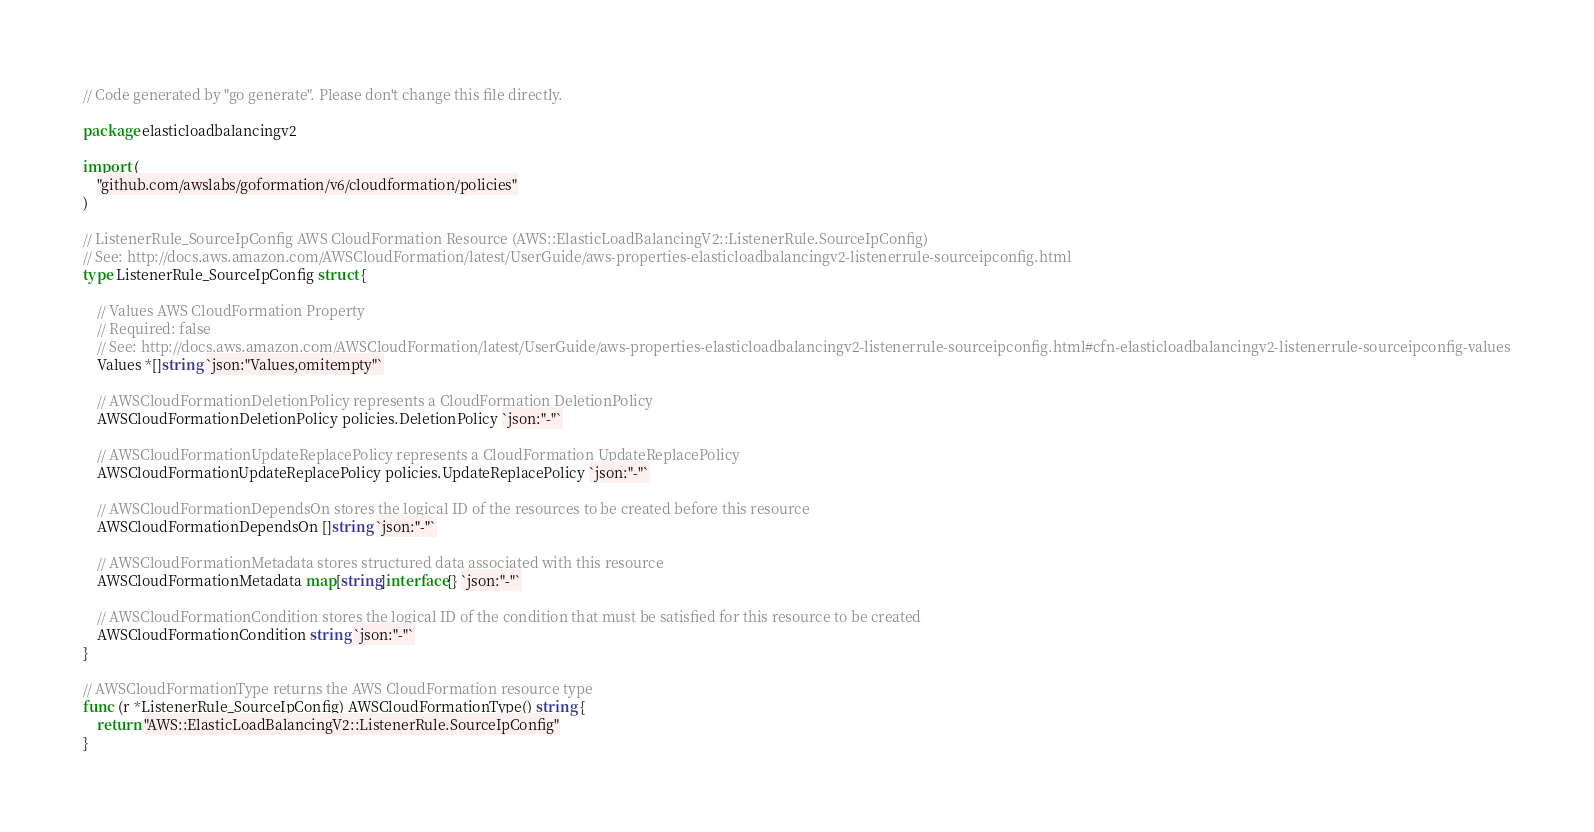Convert code to text. <code><loc_0><loc_0><loc_500><loc_500><_Go_>// Code generated by "go generate". Please don't change this file directly.

package elasticloadbalancingv2

import (
	"github.com/awslabs/goformation/v6/cloudformation/policies"
)

// ListenerRule_SourceIpConfig AWS CloudFormation Resource (AWS::ElasticLoadBalancingV2::ListenerRule.SourceIpConfig)
// See: http://docs.aws.amazon.com/AWSCloudFormation/latest/UserGuide/aws-properties-elasticloadbalancingv2-listenerrule-sourceipconfig.html
type ListenerRule_SourceIpConfig struct {

	// Values AWS CloudFormation Property
	// Required: false
	// See: http://docs.aws.amazon.com/AWSCloudFormation/latest/UserGuide/aws-properties-elasticloadbalancingv2-listenerrule-sourceipconfig.html#cfn-elasticloadbalancingv2-listenerrule-sourceipconfig-values
	Values *[]string `json:"Values,omitempty"`

	// AWSCloudFormationDeletionPolicy represents a CloudFormation DeletionPolicy
	AWSCloudFormationDeletionPolicy policies.DeletionPolicy `json:"-"`

	// AWSCloudFormationUpdateReplacePolicy represents a CloudFormation UpdateReplacePolicy
	AWSCloudFormationUpdateReplacePolicy policies.UpdateReplacePolicy `json:"-"`

	// AWSCloudFormationDependsOn stores the logical ID of the resources to be created before this resource
	AWSCloudFormationDependsOn []string `json:"-"`

	// AWSCloudFormationMetadata stores structured data associated with this resource
	AWSCloudFormationMetadata map[string]interface{} `json:"-"`

	// AWSCloudFormationCondition stores the logical ID of the condition that must be satisfied for this resource to be created
	AWSCloudFormationCondition string `json:"-"`
}

// AWSCloudFormationType returns the AWS CloudFormation resource type
func (r *ListenerRule_SourceIpConfig) AWSCloudFormationType() string {
	return "AWS::ElasticLoadBalancingV2::ListenerRule.SourceIpConfig"
}
</code> 